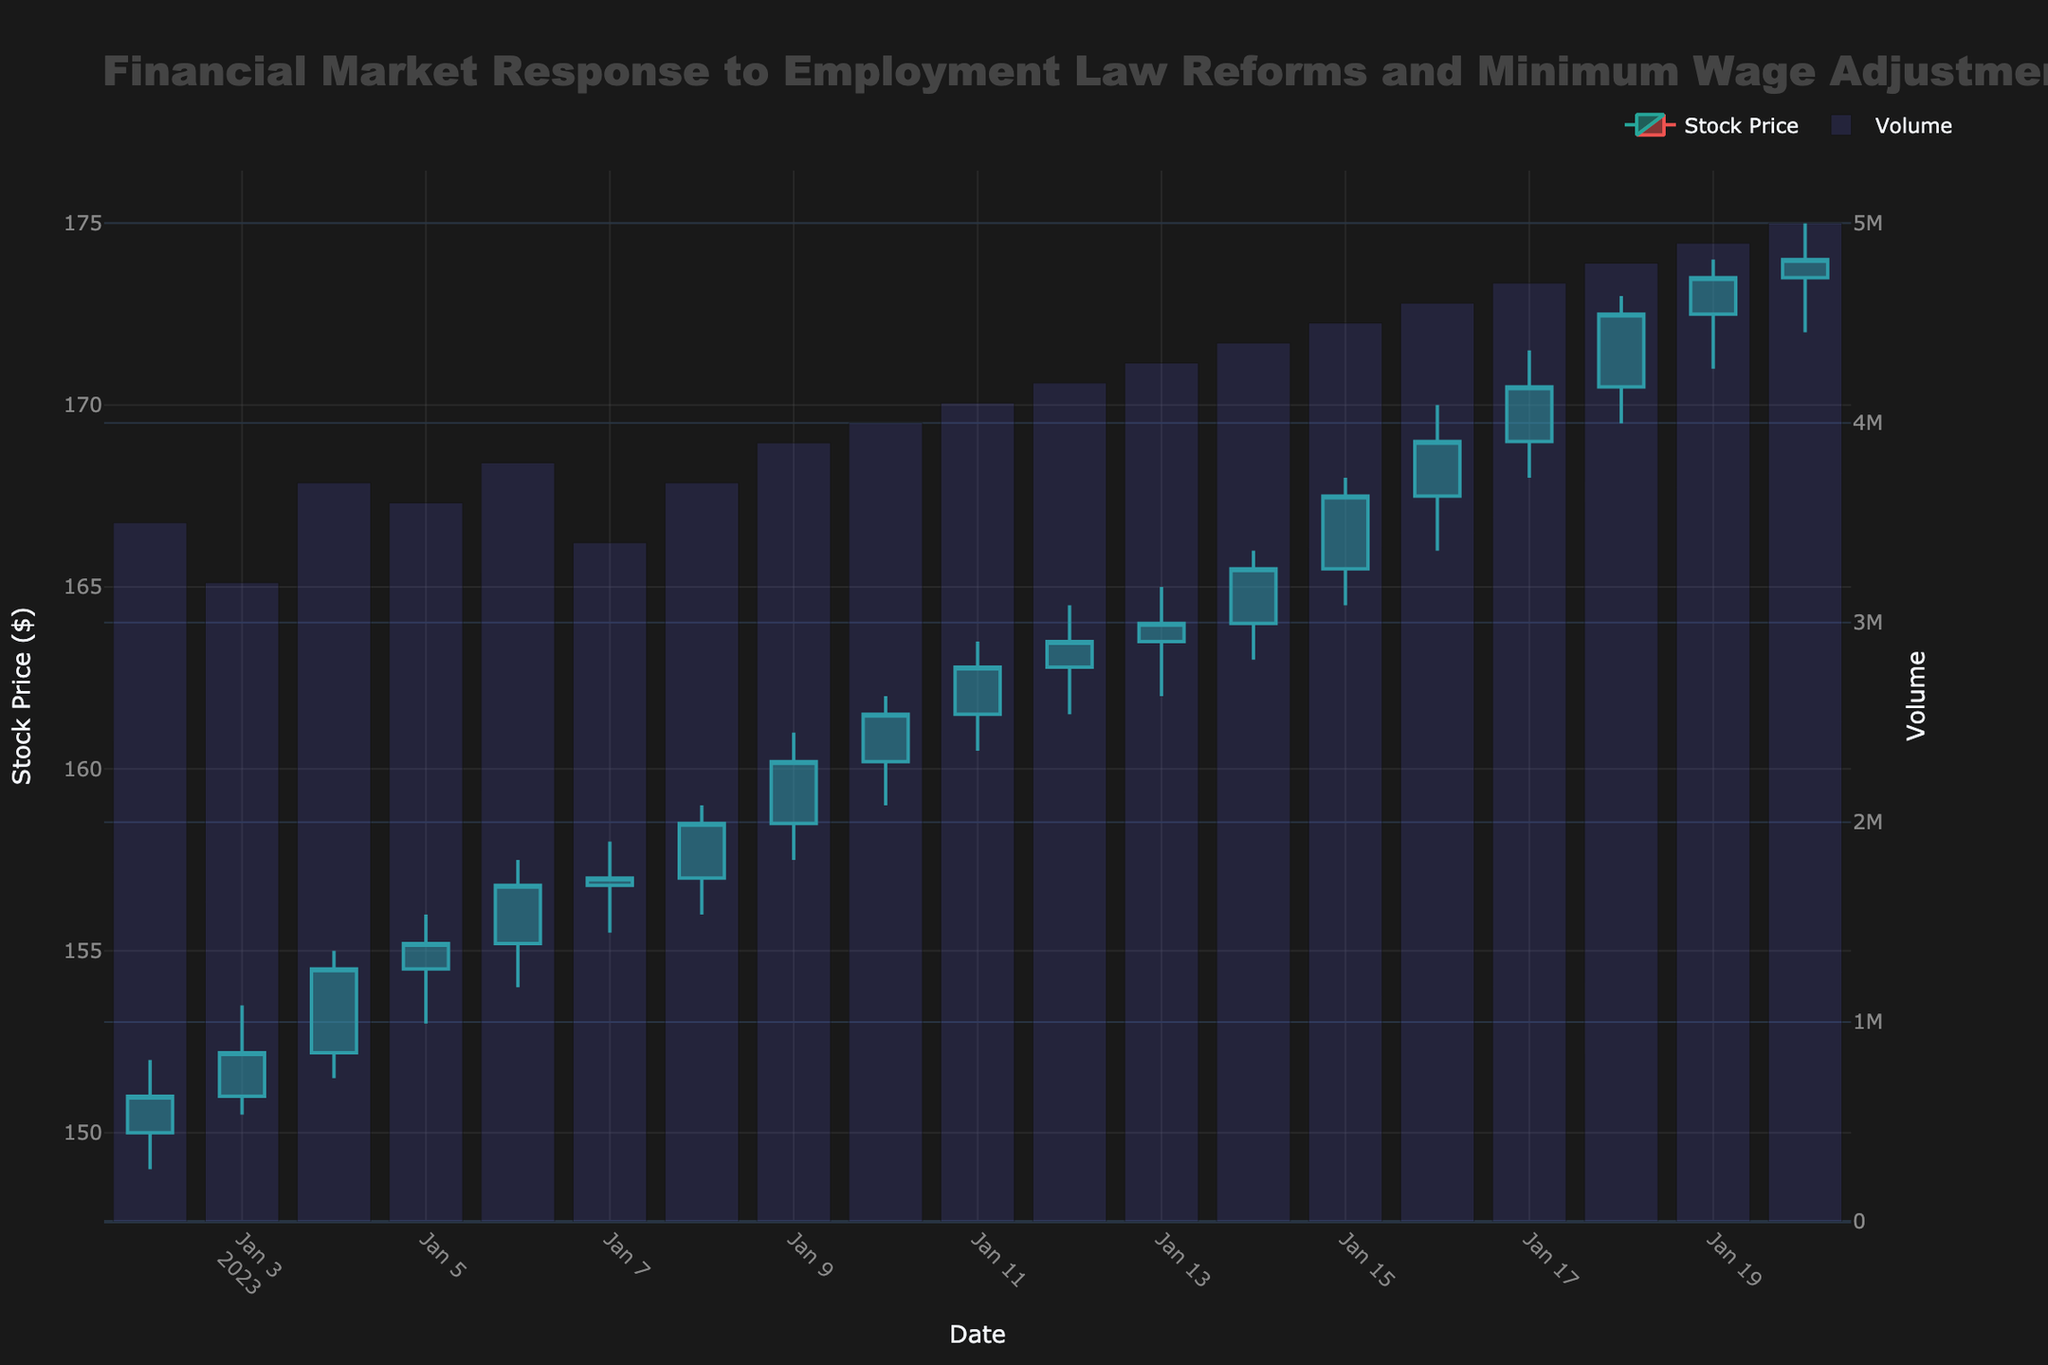What is the title of the figure? The title is displayed at the top center of the figure in large, bold text. It provides the context and purpose of the visualization.
Answer: Financial Market Response to Employment Law Reforms and Minimum Wage Adjustments How many trading days are represented in this figure? Count the number of bars or candlesticks along the x-axis, one for each trading day.
Answer: 19 On which date did the stock price close at its highest value? Look for the tallest candlestick or bar corresponding to the closing price on the y-axis.
Answer: January 20, 2023 How does the stock price trend from January 2 to January 20? Observe the general movement of the candlesticks from the start to the end date, noting any increases or decreases. The stock price starts at $151 and ends at $174, showing an upward trend.
Answer: Upward What was the trading volume on January 11, 2023? Find the bar corresponding to January 11 on the secondary y-axis, where the trading volume is indicated.
Answer: 4,100,000 What is the average closing price from January 2, 2023, to January 20, 2023? Sum the closing prices from each day and divide by the number of days. The calculation is (151 + 152.2 + 154.5 + 155.2 + 156.8 + 157 + 158.5 + 160.2 + 161.5 + 162.8 + 163.5 + 164 + 165.5 + 167.5 + 169 + 170.5 + 172.5 + 173.5 + 174) / 19.
Answer: $162.78 Between which two dates did the stock price experience the largest increase? Identify and compare the difference between the closing and starting prices of consecutive days. The largest increase is from January 15 ($167.50) to January 16 ($169.00). The increase is $169 - $167.50 = $1.50.
Answer: January 15 and January 16 Which day had the highest trading volume and what was the volume? Look at the heights of the volume bars and identify the tallest one. Check the corresponding date and volume.
Answer: January 20, 2023; 5,000,000 Did the stock price ever drop below the opening price on January 5, 2023? If so, on which date? The opening price on January 5 was $154.50. Look for any candlestick where the closing price is less than $154.50. The price dropped below $154.50 on January 2 ($151.00), January 3 ($152.20), and January 4 ($154.50).
Answer: Yes; January 2, January 3, January 4 What are the increasing and decreasing line colors in the candlestick plot? Observe the colors of the candlestick lines in the plot. The increasing lines are in green, and the decreasing lines are in red.
Answer: Green and Red 